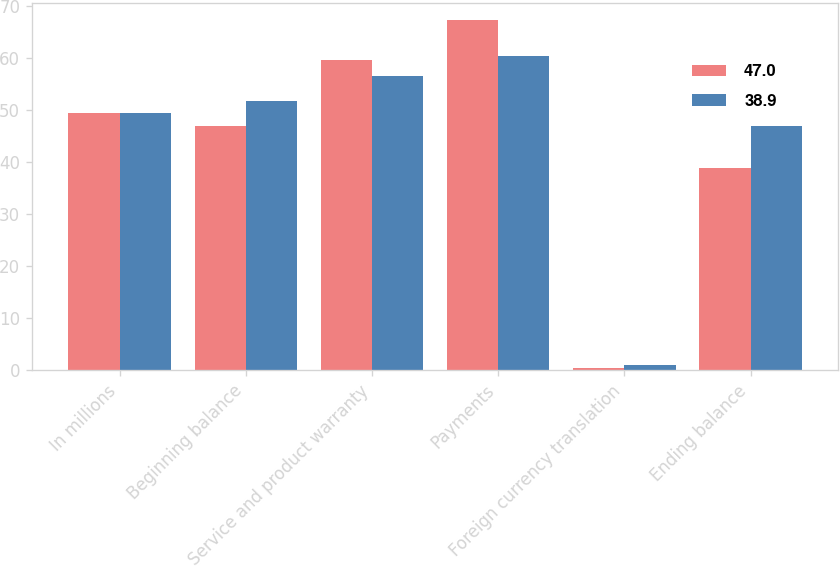<chart> <loc_0><loc_0><loc_500><loc_500><stacked_bar_chart><ecel><fcel>In millions<fcel>Beginning balance<fcel>Service and product warranty<fcel>Payments<fcel>Foreign currency translation<fcel>Ending balance<nl><fcel>47<fcel>49.4<fcel>47<fcel>59.7<fcel>67.3<fcel>0.5<fcel>38.9<nl><fcel>38.9<fcel>49.4<fcel>51.8<fcel>56.6<fcel>60.4<fcel>1<fcel>47<nl></chart> 